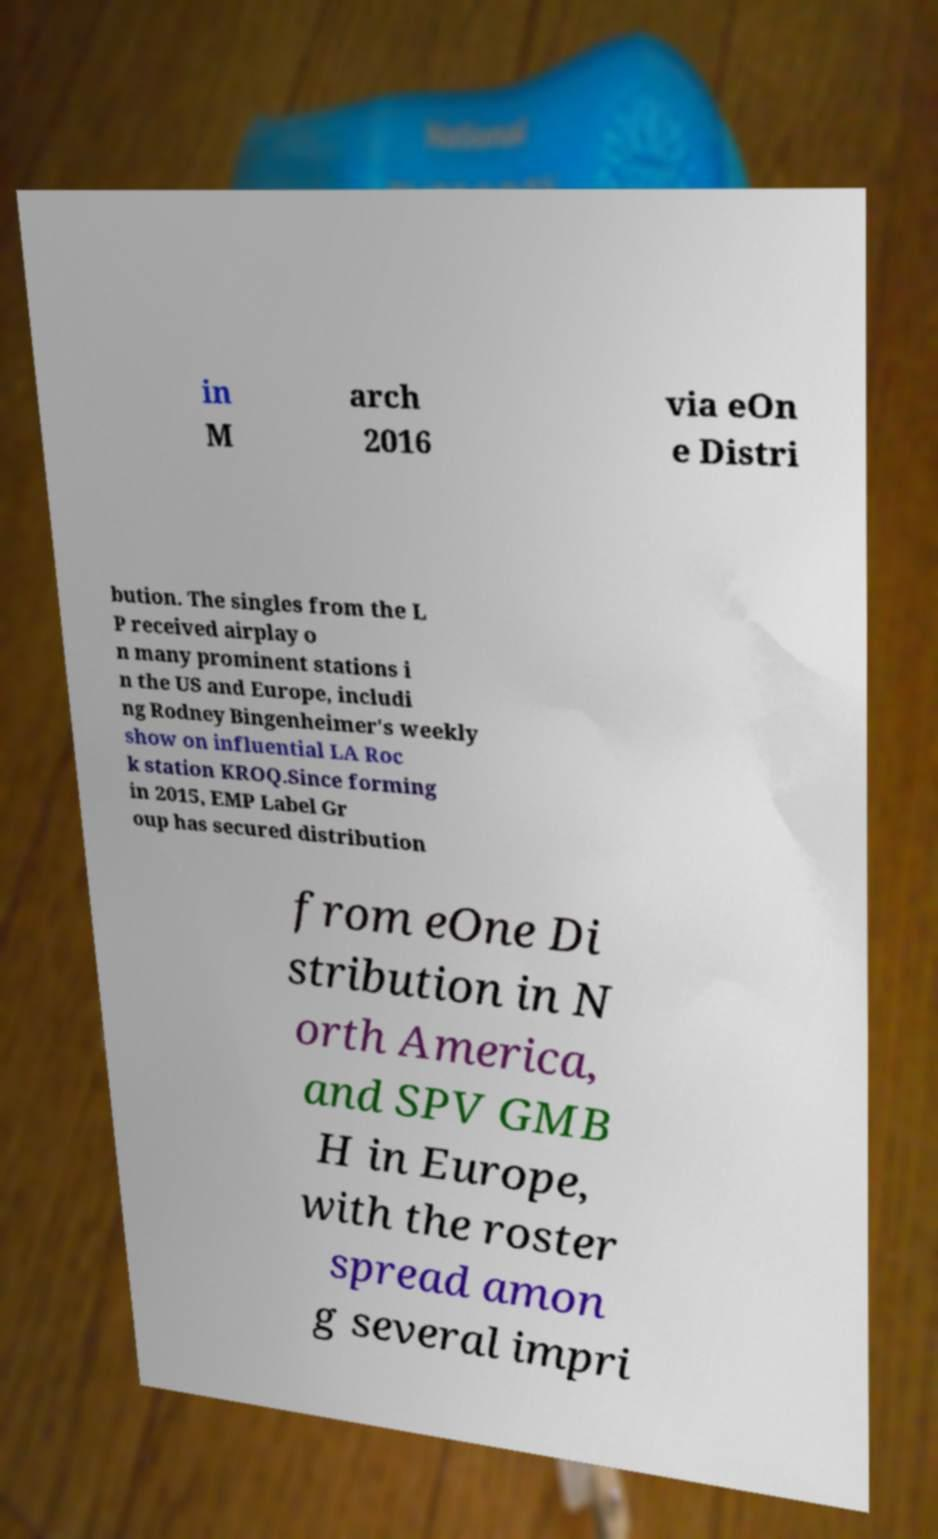I need the written content from this picture converted into text. Can you do that? in M arch 2016 via eOn e Distri bution. The singles from the L P received airplay o n many prominent stations i n the US and Europe, includi ng Rodney Bingenheimer's weekly show on influential LA Roc k station KROQ.Since forming in 2015, EMP Label Gr oup has secured distribution from eOne Di stribution in N orth America, and SPV GMB H in Europe, with the roster spread amon g several impri 